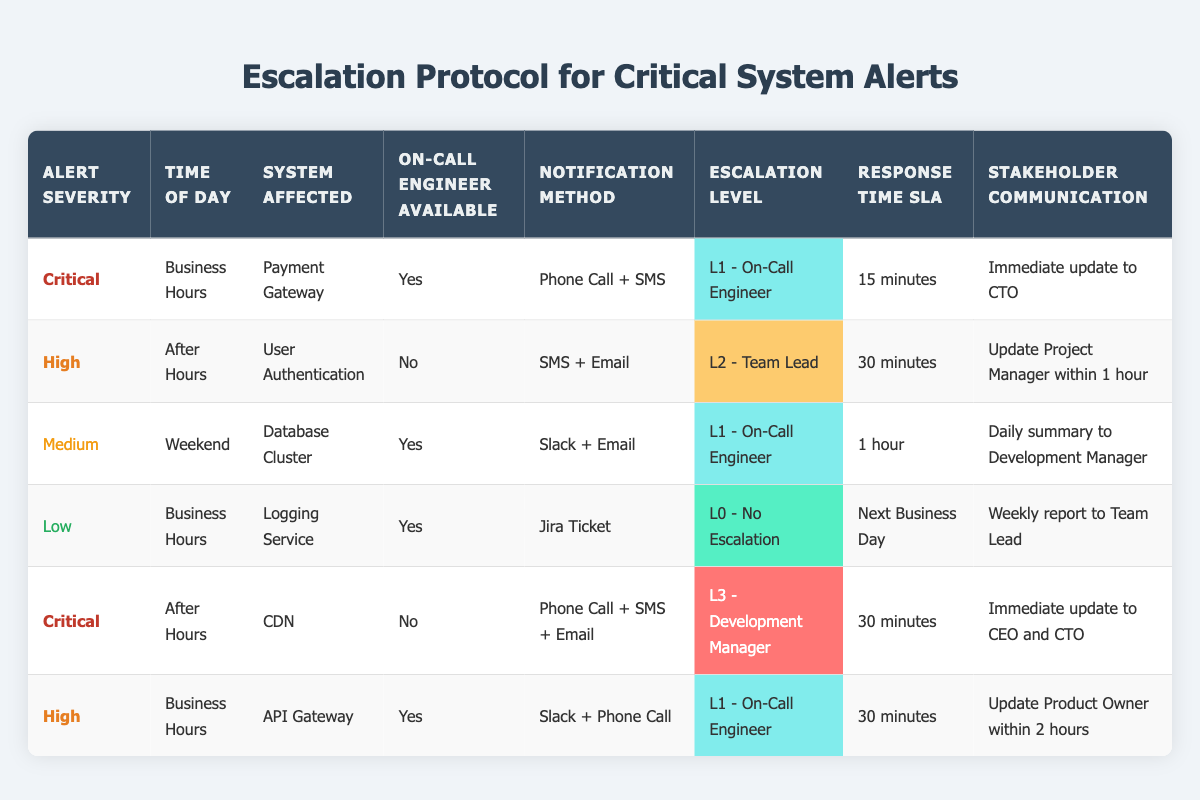What notification method is used for a critical alert during business hours? For a critical alert during business hours, the notification method specified in the table is "Phone Call + SMS." This can be found in the first row of the table under the corresponding columns for "Alert Severity," "Time of Day," and "Notification Method."
Answer: Phone Call + SMS Is there an on-call engineer available for high severity alerts after hours? In the second rule of the table, it states that for a high severity alert occurring after hours, the on-call engineer is "No." Therefore, according to this data, there is no on-call engineer available during that time.
Answer: No What is the response time SLA for medium severity alerts during the weekend? The response time SLA for medium severity alerts during the weekend is listed in the third rule of the table, which specifies a response time of "1 hour." This information can be directly retrieved from the corresponding row for medium severity alerts.
Answer: 1 hour Which escalation level applies when there is no on-call engineer for a critical alert after hours? The table indicates that for a critical alert after hours with no on-call engineer available (found in the fifth rule), the escalation level is "L3 - Development Manager." This can be seen in the row that matches these conditions.
Answer: L3 - Development Manager What are the stakeholder communication expectations for high severity alerts during business hours? In the table, the stakeholder communication expectation for high severity alerts during business hours is an "Update Product Owner within 2 hours." This is specified in the last column corresponding to the rule that describes these conditions.
Answer: Update Product Owner within 2 hours How many different escalation levels are specified for medium severity alerts? The table lists a total of two different escalation levels specifically for medium severity alerts, provided in the third rule. Since medium severity alerts have a consistent escalation to the "L1 - On-Call Engineer," there is only one unique escalation level applicable.
Answer: 1 Is SMS included as a notification method for all critical alerts? By examining the table closely, SMS is included as a notification method for both critical alerts listed (in the first and fifth rules). Therefore, it is true that SMS is part of the notification methods for both critical situations described.
Answer: Yes During which time of day is the logging service alert addressed, and what is its response time SLA? Referring to the fourth rule in the table, the logging service alert is addressed during "Business Hours" and has a response time SLA of "Next Business Day." This information is directly provided in the respective columns.
Answer: Business Hours, Next Business Day What is the difference in response time SLA between high severity alerts after hours and critical alerts after hours? High severity alerts after hours (the second rule) have a response time SLA of "30 minutes." On the other hand, critical alerts after hours (the fifth rule) also have a response time SLA of "30 minutes." As both SLAs are equal, the difference is zero.
Answer: 0 minutes 